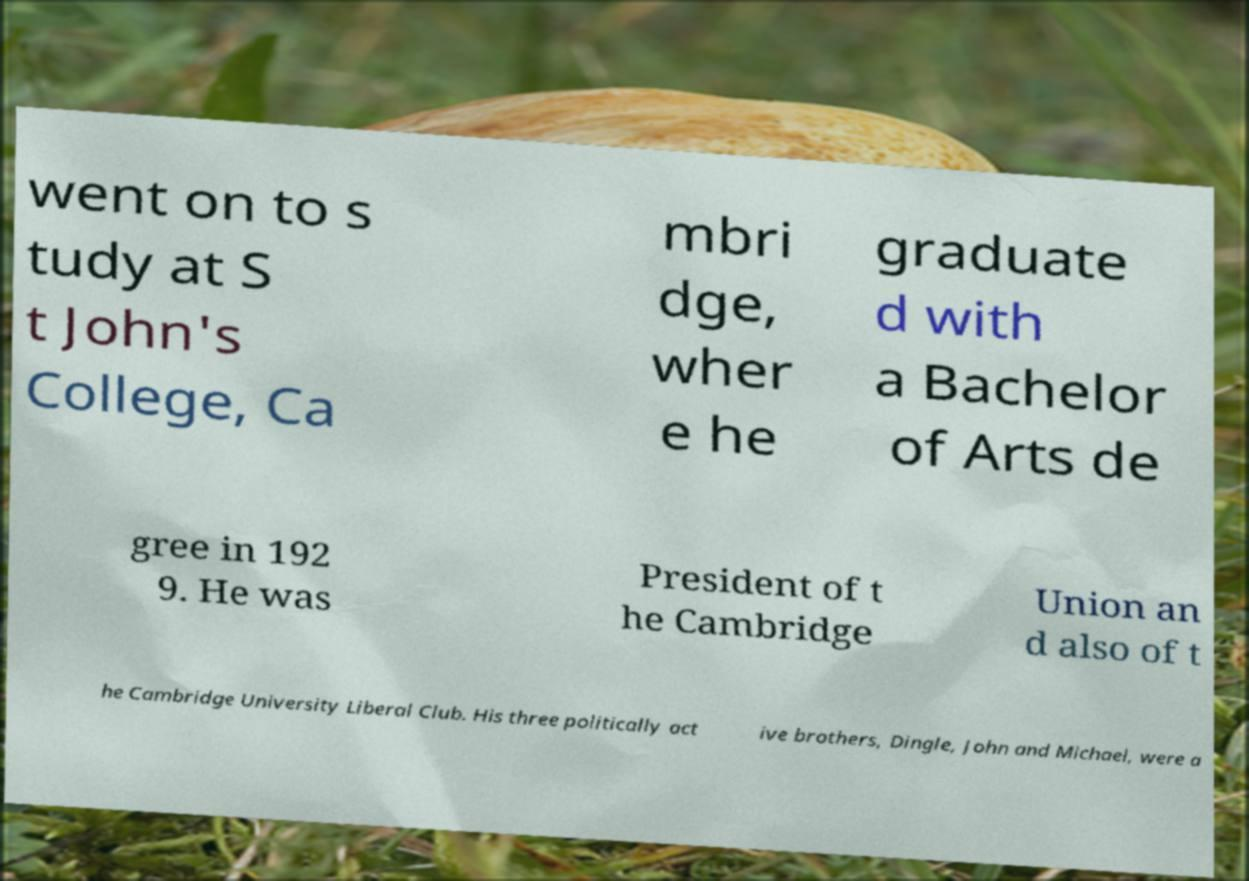Can you accurately transcribe the text from the provided image for me? went on to s tudy at S t John's College, Ca mbri dge, wher e he graduate d with a Bachelor of Arts de gree in 192 9. He was President of t he Cambridge Union an d also of t he Cambridge University Liberal Club. His three politically act ive brothers, Dingle, John and Michael, were a 